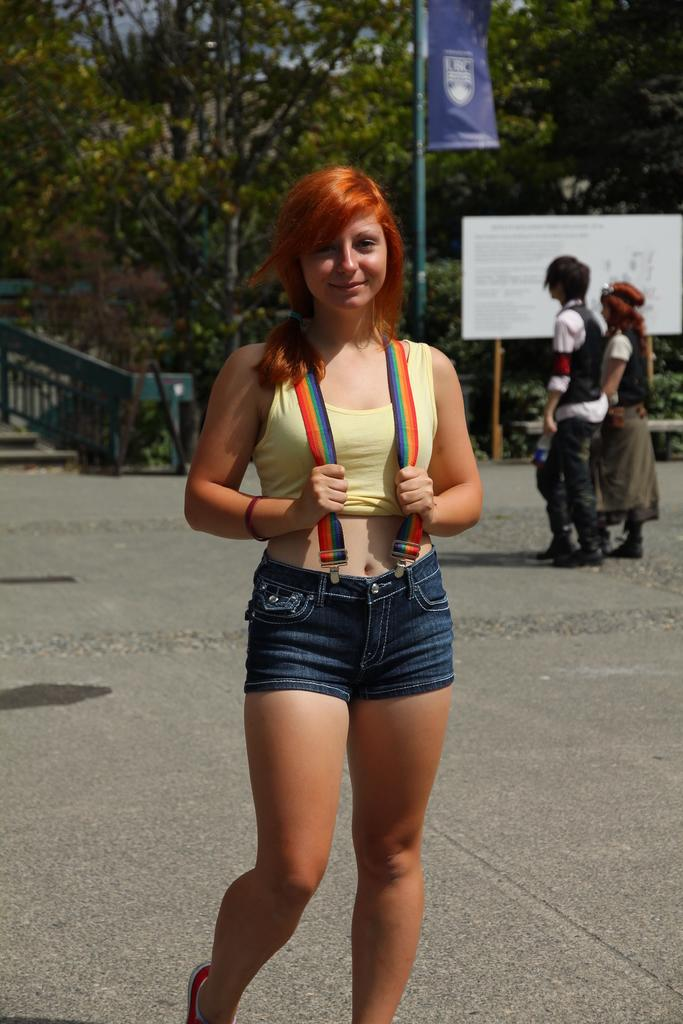What is the person in the foreground of the image doing? The person is standing and smiling in the image. What can be seen happening in the background of the image? There are two persons walking in the background of the image. What structures are visible in the background of the image? There are boards with poles in the background of the image. What type of natural elements can be seen in the background of the image? Trees are present in the background of the image. What type of dust can be seen covering the trees in the image? There is no dust visible in the image; the trees appear to be clear of any dust or debris. 